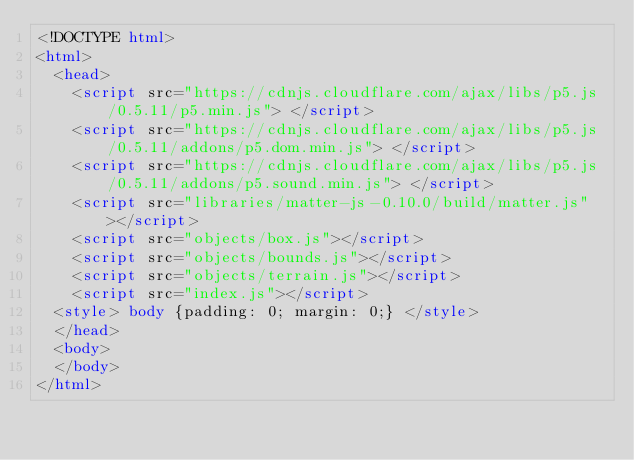Convert code to text. <code><loc_0><loc_0><loc_500><loc_500><_HTML_><!DOCTYPE html>
<html>
  <head>
    <script src="https://cdnjs.cloudflare.com/ajax/libs/p5.js/0.5.11/p5.min.js"> </script>
    <script src="https://cdnjs.cloudflare.com/ajax/libs/p5.js/0.5.11/addons/p5.dom.min.js"> </script>
    <script src="https://cdnjs.cloudflare.com/ajax/libs/p5.js/0.5.11/addons/p5.sound.min.js"> </script>
    <script src="libraries/matter-js-0.10.0/build/matter.js"></script>
    <script src="objects/box.js"></script>
    <script src="objects/bounds.js"></script>
    <script src="objects/terrain.js"></script>
    <script src="index.js"></script>
  <style> body {padding: 0; margin: 0;} </style>
  </head>
  <body>
  </body>
</html>
</code> 